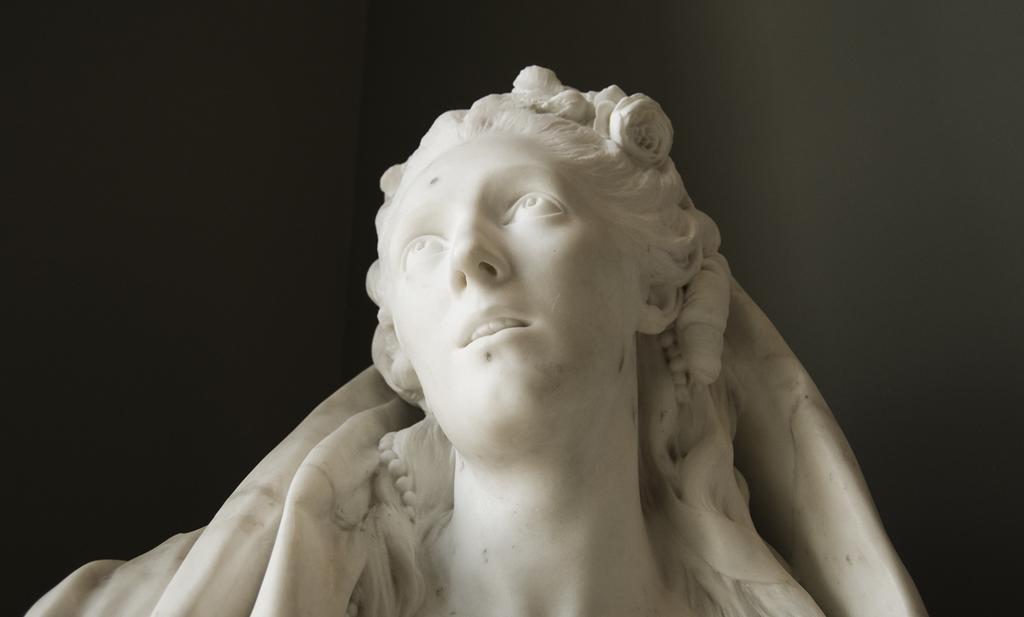What is the main subject of the image? There is a statue of a lady in the image. What is the color of the statue? The statue is white in color. What can be seen in the background of the image? There is a dark background in the image. How far away is the battlefield from the statue in the image? There is no battlefield or distance mentioned in the image; it only features a statue of a lady with a dark background. 